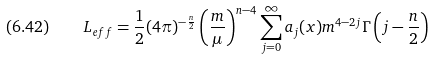<formula> <loc_0><loc_0><loc_500><loc_500>( 6 . 4 2 ) \quad L _ { e f f } = \frac { 1 } { 2 } ( 4 \pi ) ^ { - \frac { n } { 2 } } \left ( \frac { m } { \mu } \right ) ^ { n - 4 } \sum _ { j = 0 } ^ { \infty } a _ { j } ( x ) m ^ { 4 - 2 j } \Gamma \left ( j - \frac { n } { 2 } \right )</formula> 